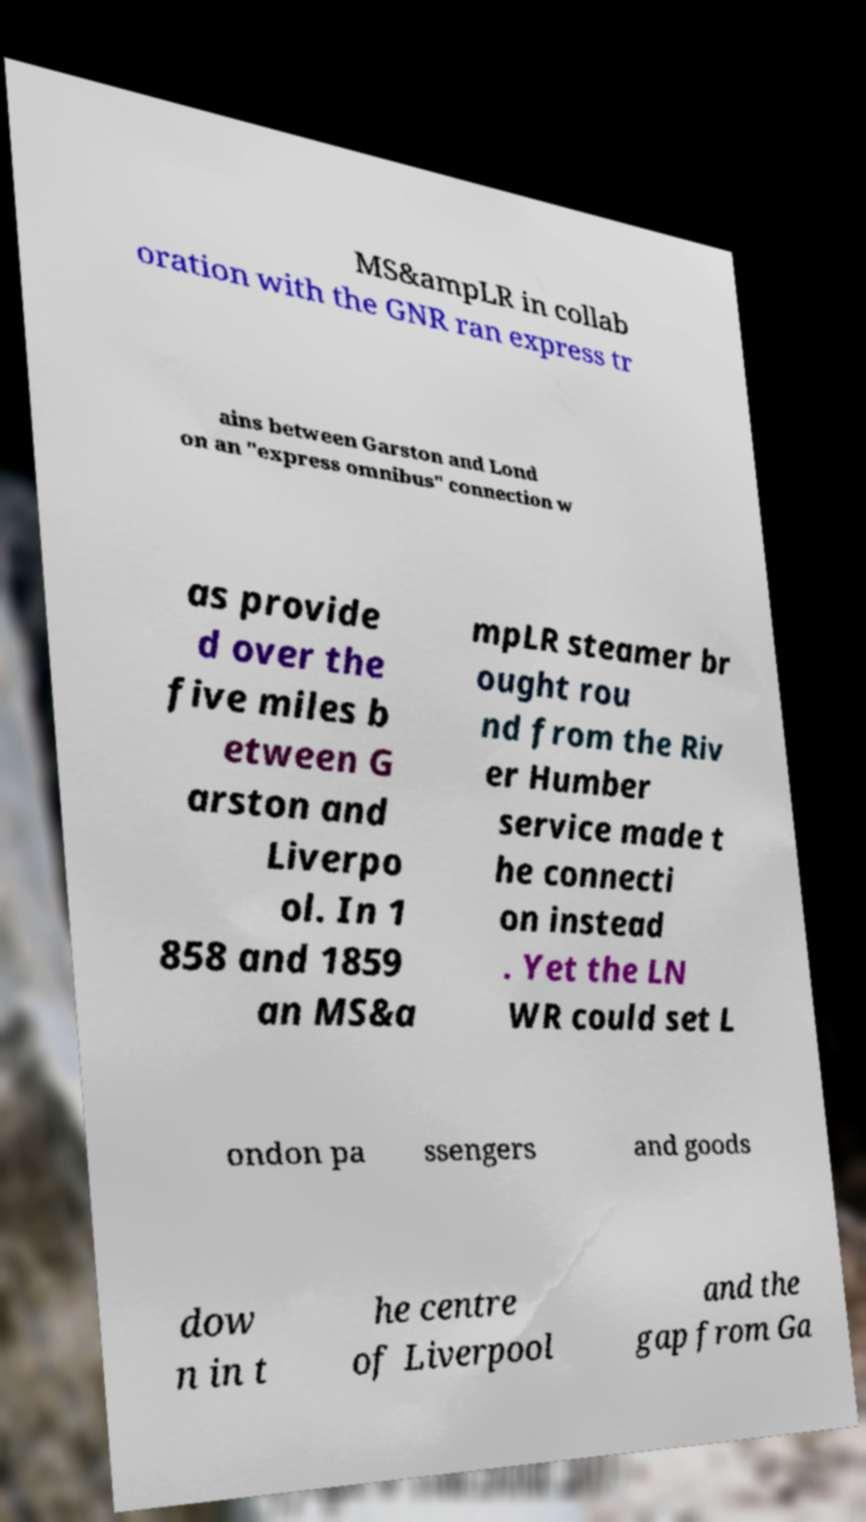What messages or text are displayed in this image? I need them in a readable, typed format. MS&ampLR in collab oration with the GNR ran express tr ains between Garston and Lond on an "express omnibus" connection w as provide d over the five miles b etween G arston and Liverpo ol. In 1 858 and 1859 an MS&a mpLR steamer br ought rou nd from the Riv er Humber service made t he connecti on instead . Yet the LN WR could set L ondon pa ssengers and goods dow n in t he centre of Liverpool and the gap from Ga 